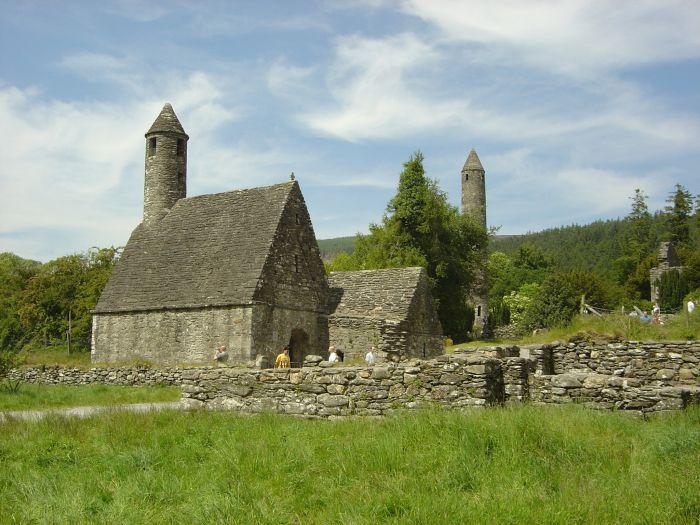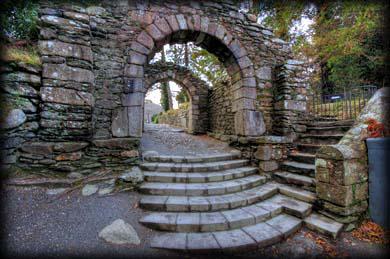The first image is the image on the left, the second image is the image on the right. Assess this claim about the two images: "An image shows an old gray building featuring a cone-topped tower in the foreground, with no water or bridge visible.". Correct or not? Answer yes or no. Yes. 